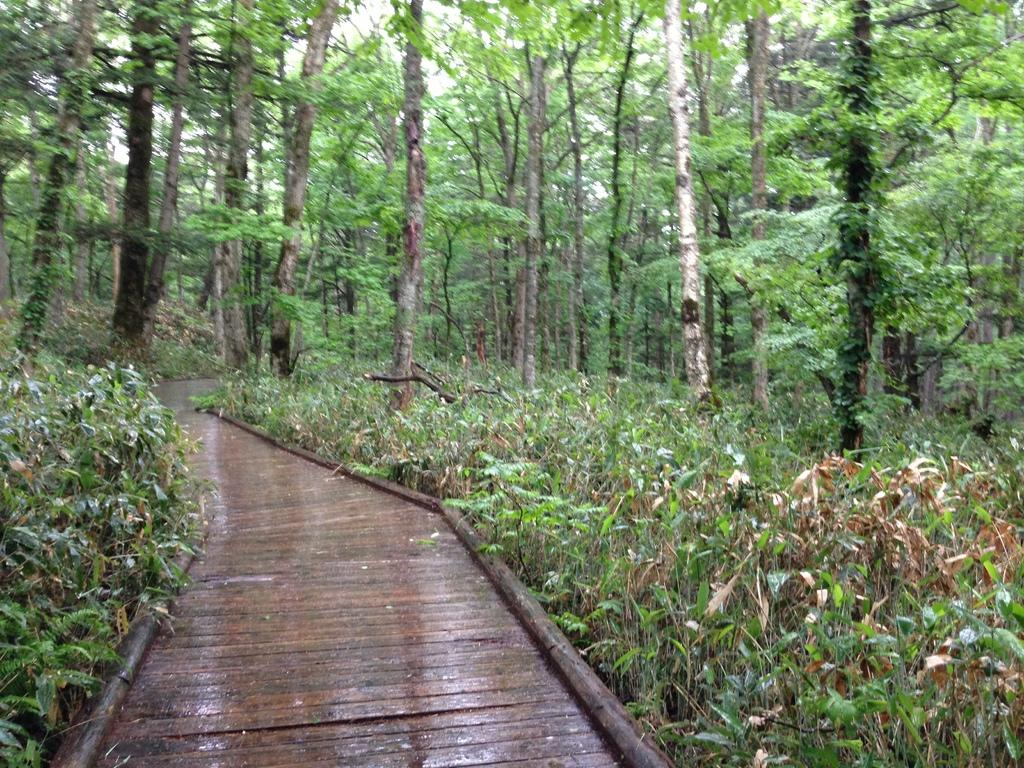What type of path is visible at the bottom of the image? There is a wooden walkway at the bottom of the image. What can be seen on both sides of the image? There are trees on either side of the image. What type of boot is hanging from the tree in the image? There is no boot hanging from a tree in the image; only the wooden walkway and trees are present. 